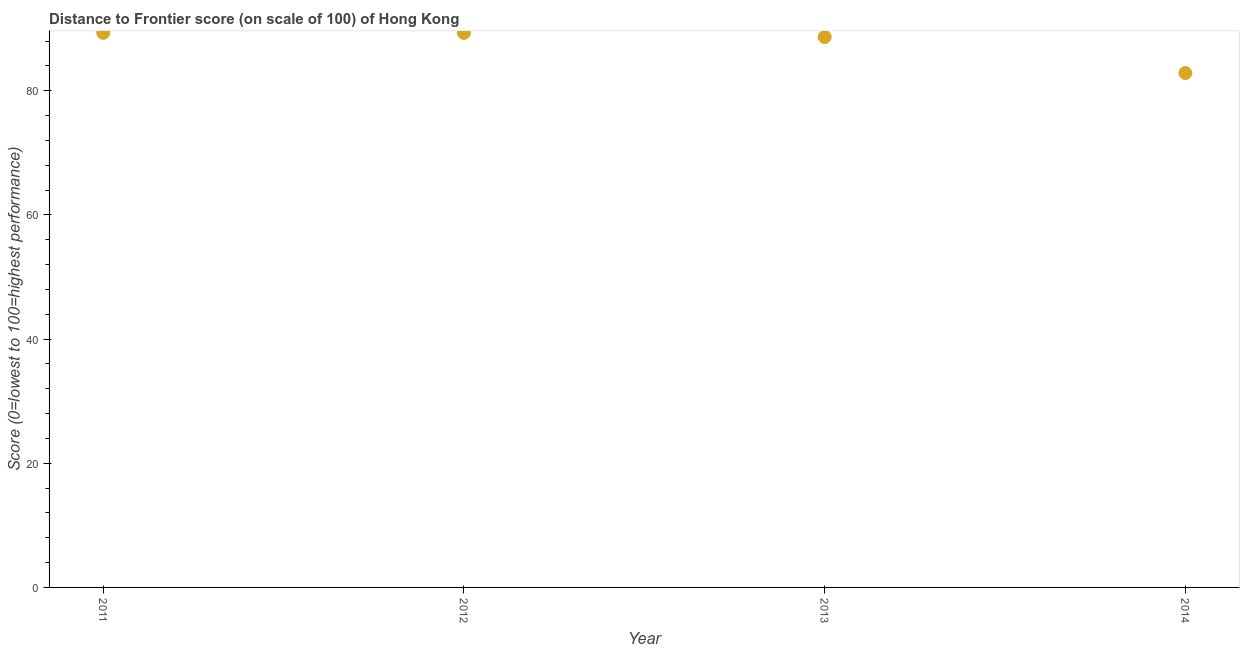What is the distance to frontier score in 2011?
Provide a short and direct response. 89.34. Across all years, what is the maximum distance to frontier score?
Give a very brief answer. 89.34. Across all years, what is the minimum distance to frontier score?
Keep it short and to the point. 82.87. In which year was the distance to frontier score minimum?
Your answer should be very brief. 2014. What is the sum of the distance to frontier score?
Offer a very short reply. 350.21. What is the difference between the distance to frontier score in 2012 and 2014?
Keep it short and to the point. 6.46. What is the average distance to frontier score per year?
Your answer should be compact. 87.55. What is the median distance to frontier score?
Offer a terse response. 89. In how many years, is the distance to frontier score greater than 44 ?
Make the answer very short. 4. What is the ratio of the distance to frontier score in 2011 to that in 2012?
Give a very brief answer. 1. Is the distance to frontier score in 2011 less than that in 2014?
Give a very brief answer. No. Is the difference between the distance to frontier score in 2011 and 2013 greater than the difference between any two years?
Your response must be concise. No. What is the difference between the highest and the second highest distance to frontier score?
Provide a short and direct response. 0.01. What is the difference between the highest and the lowest distance to frontier score?
Provide a short and direct response. 6.47. In how many years, is the distance to frontier score greater than the average distance to frontier score taken over all years?
Keep it short and to the point. 3. Does the distance to frontier score monotonically increase over the years?
Provide a succinct answer. No. How many dotlines are there?
Your answer should be very brief. 1. How many years are there in the graph?
Give a very brief answer. 4. Are the values on the major ticks of Y-axis written in scientific E-notation?
Your answer should be compact. No. Does the graph contain grids?
Your answer should be very brief. No. What is the title of the graph?
Offer a very short reply. Distance to Frontier score (on scale of 100) of Hong Kong. What is the label or title of the X-axis?
Provide a succinct answer. Year. What is the label or title of the Y-axis?
Your answer should be compact. Score (0=lowest to 100=highest performance). What is the Score (0=lowest to 100=highest performance) in 2011?
Offer a very short reply. 89.34. What is the Score (0=lowest to 100=highest performance) in 2012?
Your response must be concise. 89.33. What is the Score (0=lowest to 100=highest performance) in 2013?
Make the answer very short. 88.67. What is the Score (0=lowest to 100=highest performance) in 2014?
Keep it short and to the point. 82.87. What is the difference between the Score (0=lowest to 100=highest performance) in 2011 and 2013?
Offer a very short reply. 0.67. What is the difference between the Score (0=lowest to 100=highest performance) in 2011 and 2014?
Offer a terse response. 6.47. What is the difference between the Score (0=lowest to 100=highest performance) in 2012 and 2013?
Provide a succinct answer. 0.66. What is the difference between the Score (0=lowest to 100=highest performance) in 2012 and 2014?
Keep it short and to the point. 6.46. What is the difference between the Score (0=lowest to 100=highest performance) in 2013 and 2014?
Make the answer very short. 5.8. What is the ratio of the Score (0=lowest to 100=highest performance) in 2011 to that in 2014?
Give a very brief answer. 1.08. What is the ratio of the Score (0=lowest to 100=highest performance) in 2012 to that in 2013?
Provide a succinct answer. 1.01. What is the ratio of the Score (0=lowest to 100=highest performance) in 2012 to that in 2014?
Offer a terse response. 1.08. What is the ratio of the Score (0=lowest to 100=highest performance) in 2013 to that in 2014?
Provide a short and direct response. 1.07. 